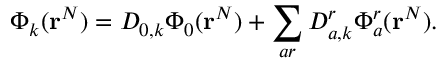<formula> <loc_0><loc_0><loc_500><loc_500>\Phi _ { k } ( r ^ { N } ) = D _ { 0 , k } \Phi _ { 0 } ( r ^ { N } ) + \sum _ { a r } D _ { a , k } ^ { r } \Phi _ { a } ^ { r } ( r ^ { N } ) .</formula> 